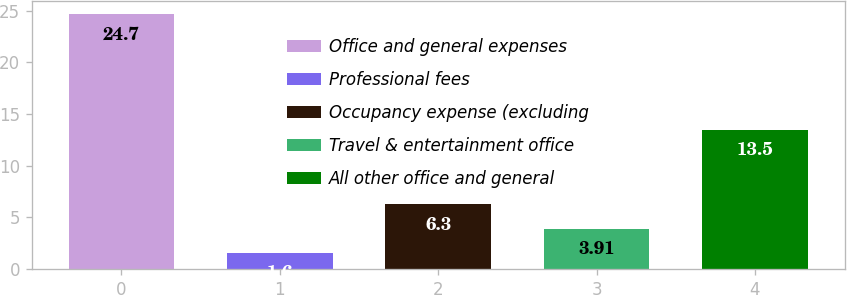<chart> <loc_0><loc_0><loc_500><loc_500><bar_chart><fcel>Office and general expenses<fcel>Professional fees<fcel>Occupancy expense (excluding<fcel>Travel & entertainment office<fcel>All other office and general<nl><fcel>24.7<fcel>1.6<fcel>6.3<fcel>3.91<fcel>13.5<nl></chart> 